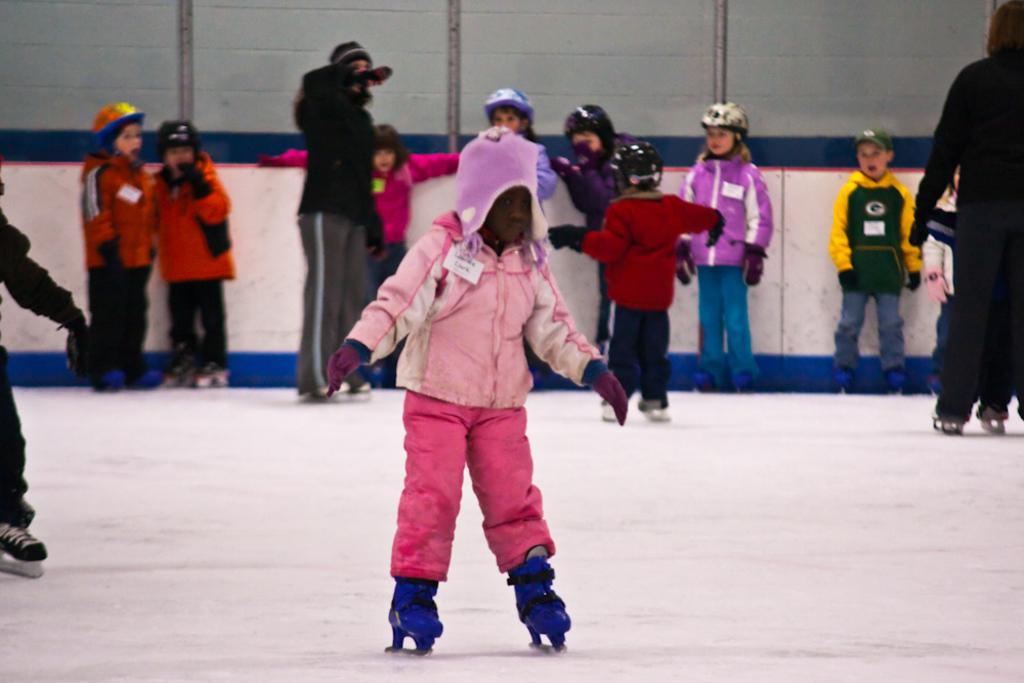What is the main activity of the kid in the image? The kid is skating in the snow. What can be seen in the background of the image? In the background, there are many kids standing in the snow. What are the kids in the background wearing? The kids in the background are wearing skates. Can you see a giraffe walking on the sidewalk in the image? No, there is no giraffe or sidewalk present in the image; it features a kid skating in the snow and other kids standing in the background. 